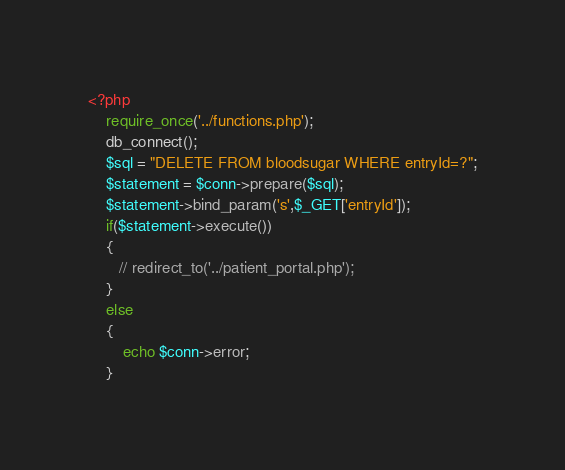<code> <loc_0><loc_0><loc_500><loc_500><_PHP_><?php
    require_once('../functions.php');
    db_connect();
    $sql = "DELETE FROM bloodsugar WHERE entryId=?";
    $statement = $conn->prepare($sql);
    $statement->bind_param('s',$_GET['entryId']);
    if($statement->execute())
    {
       // redirect_to('../patient_portal.php');
    }
    else
    {
        echo $conn->error;
    }
</code> 